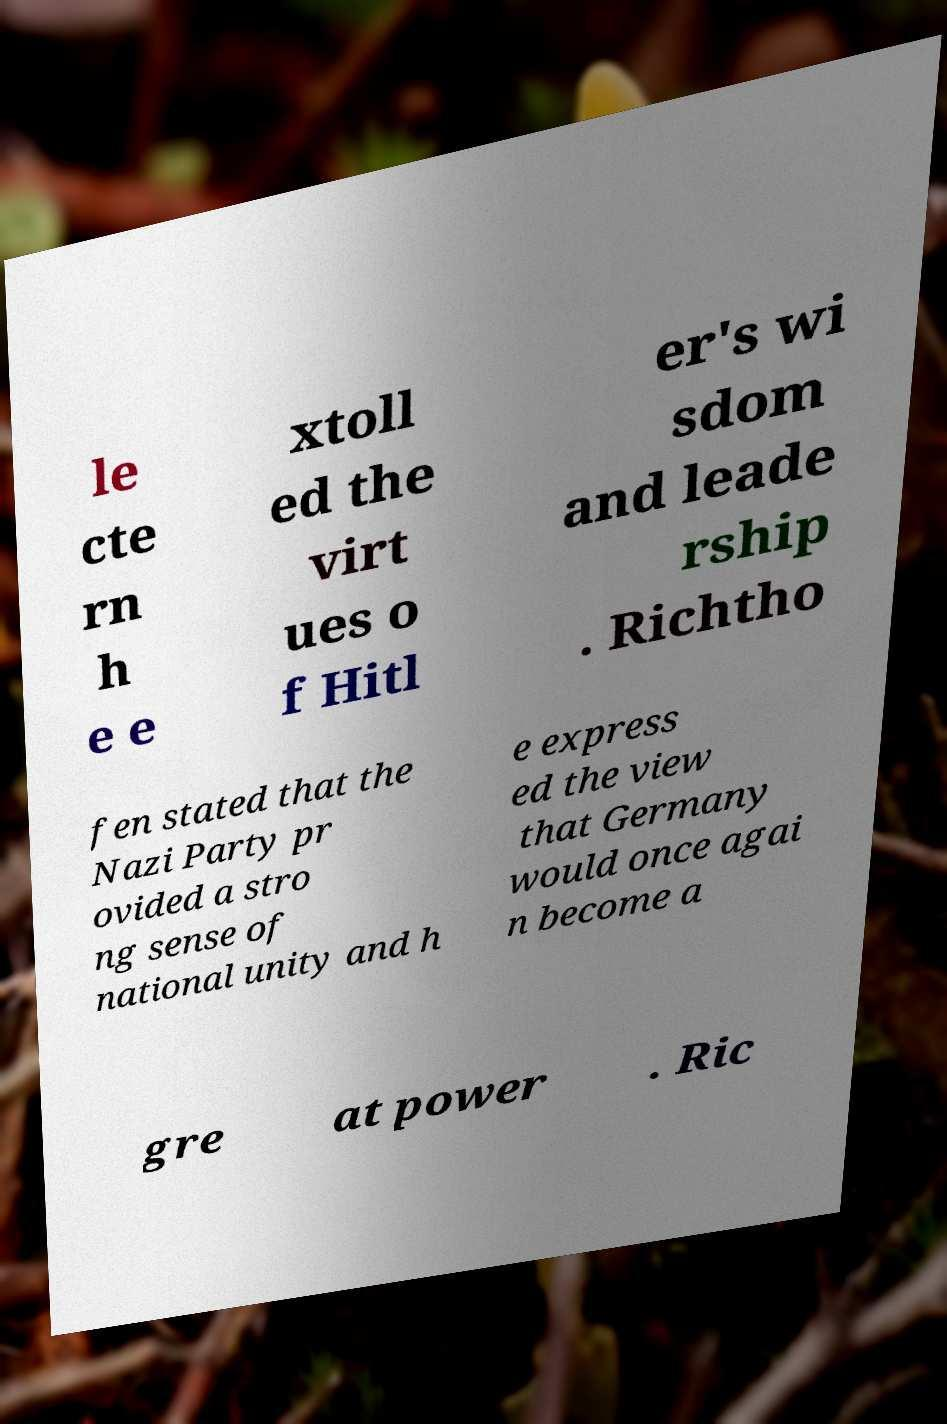Please identify and transcribe the text found in this image. le cte rn h e e xtoll ed the virt ues o f Hitl er's wi sdom and leade rship . Richtho fen stated that the Nazi Party pr ovided a stro ng sense of national unity and h e express ed the view that Germany would once agai n become a gre at power . Ric 